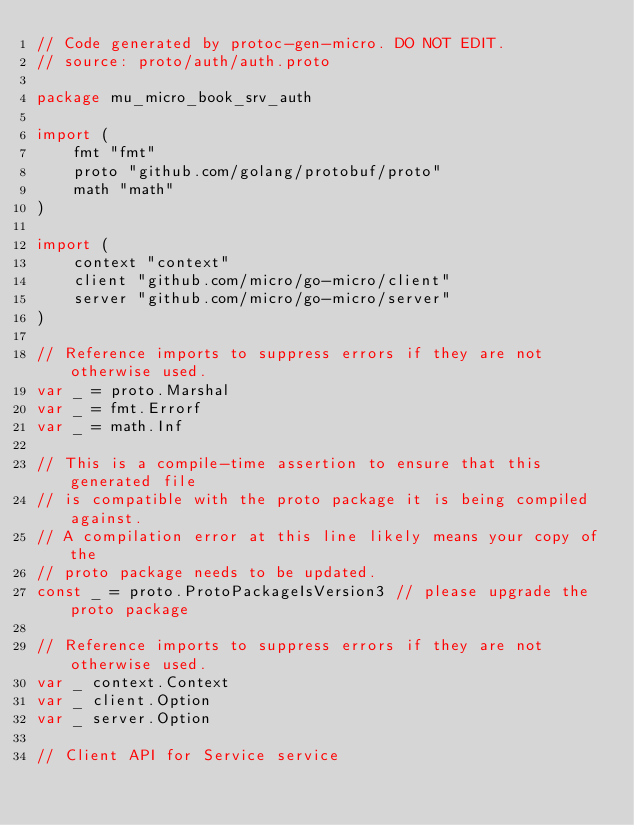<code> <loc_0><loc_0><loc_500><loc_500><_Go_>// Code generated by protoc-gen-micro. DO NOT EDIT.
// source: proto/auth/auth.proto

package mu_micro_book_srv_auth

import (
	fmt "fmt"
	proto "github.com/golang/protobuf/proto"
	math "math"
)

import (
	context "context"
	client "github.com/micro/go-micro/client"
	server "github.com/micro/go-micro/server"
)

// Reference imports to suppress errors if they are not otherwise used.
var _ = proto.Marshal
var _ = fmt.Errorf
var _ = math.Inf

// This is a compile-time assertion to ensure that this generated file
// is compatible with the proto package it is being compiled against.
// A compilation error at this line likely means your copy of the
// proto package needs to be updated.
const _ = proto.ProtoPackageIsVersion3 // please upgrade the proto package

// Reference imports to suppress errors if they are not otherwise used.
var _ context.Context
var _ client.Option
var _ server.Option

// Client API for Service service
</code> 